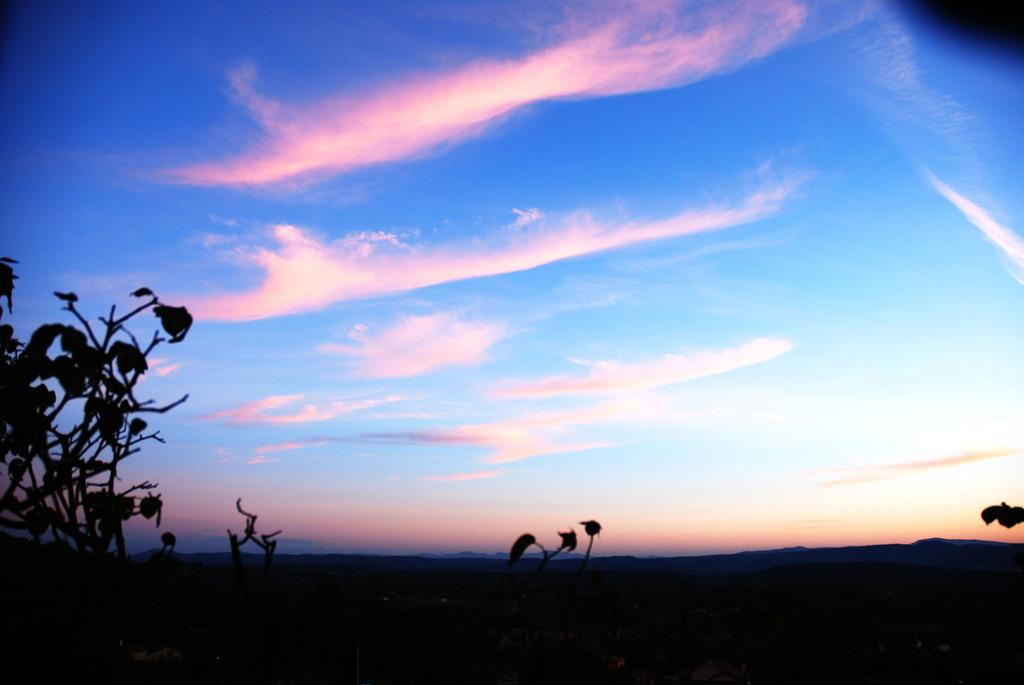What type of living organisms can be seen in the image? Plants can be seen in the image. What part of the natural environment is visible in the image? The ground and the sky are visible in the image. What can be seen in the sky in the image? Clouds are present in the sky in the image. What type of clover is being used to celebrate the birth of the new pest in the image? There is no clover, celebration, or mention of a new pest in the image; it simply features plants, ground, and sky with clouds. 